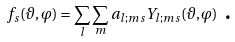<formula> <loc_0><loc_0><loc_500><loc_500>f _ { s } ( \vartheta , \varphi ) = \sum _ { l } \sum _ { m } a _ { l ; m s } Y _ { l ; m s } ( \vartheta , \varphi ) \text { .}</formula> 